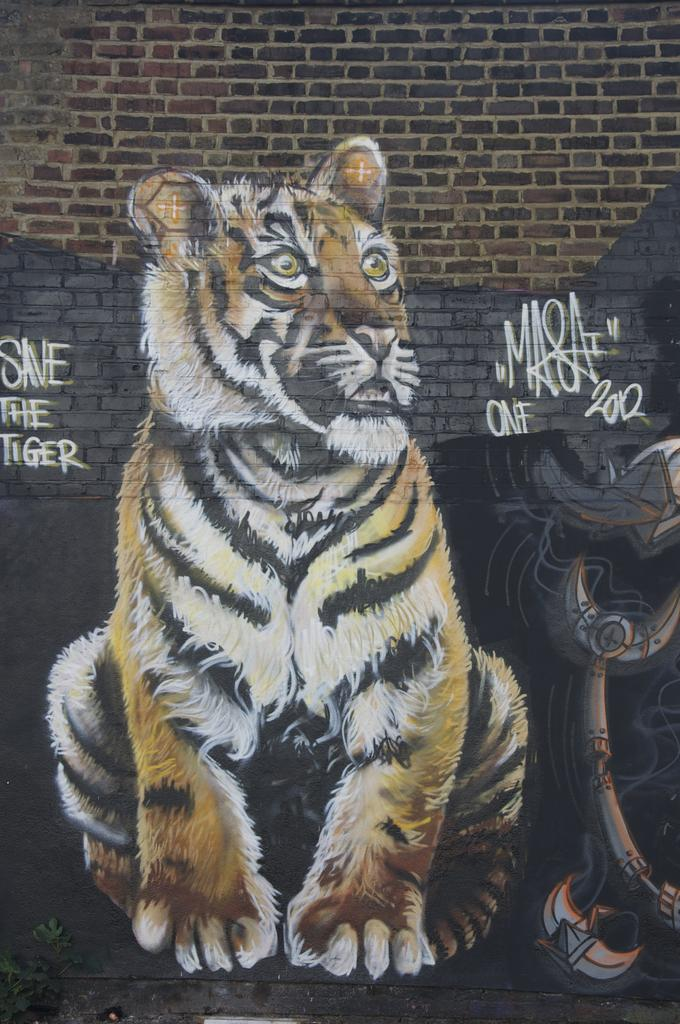What is the main subject of the image? The image is of a wall. What can be seen on the wall? There is a painting of a tiger on the wall. Are there any other objects on the wall besides the painting? Yes, there is an object on the wall. What else can be found on the wall? There is text on the wall. Is there any vegetation visible in the image? Yes, there is a plant in the bottom left corner of the image. Can you tell me how many trees are depicted in the painting of the tiger? There are no trees depicted in the painting of the tiger; it is a painting of a tiger. How many wrists are visible in the image? There are no wrists visible in the image; it is a picture of a wall with a painting and other elements. 